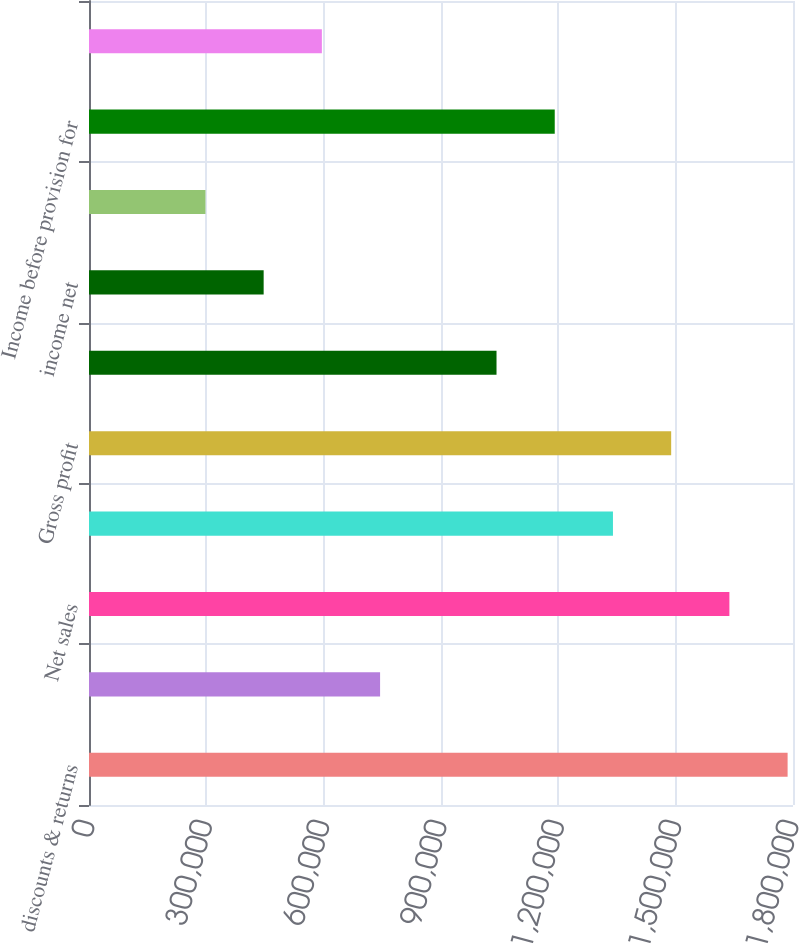<chart> <loc_0><loc_0><loc_500><loc_500><bar_chart><fcel>discounts & returns<fcel>Less Promotional and other<fcel>Net sales<fcel>Cost of sales<fcel>Gross profit<fcel>Operating expenses<fcel>income net<fcel>Gain (loss) on investments and<fcel>Income before provision for<fcel>Provision for income taxes<nl><fcel>1.78622e+06<fcel>744259<fcel>1.63737e+06<fcel>1.33966e+06<fcel>1.48852e+06<fcel>1.04196e+06<fcel>446556<fcel>297704<fcel>1.19081e+06<fcel>595407<nl></chart> 